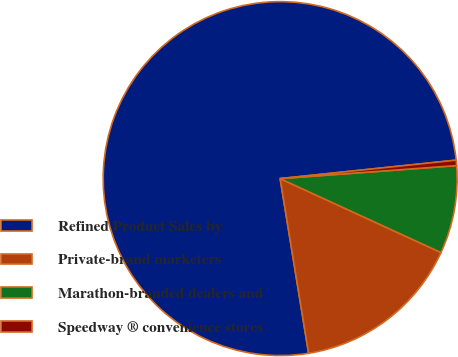Convert chart to OTSL. <chart><loc_0><loc_0><loc_500><loc_500><pie_chart><fcel>Refined Product Sales by<fcel>Private-brand marketers<fcel>Marathon-branded dealers and<fcel>Speedway ® convenience stores<nl><fcel>75.9%<fcel>15.57%<fcel>8.03%<fcel>0.49%<nl></chart> 